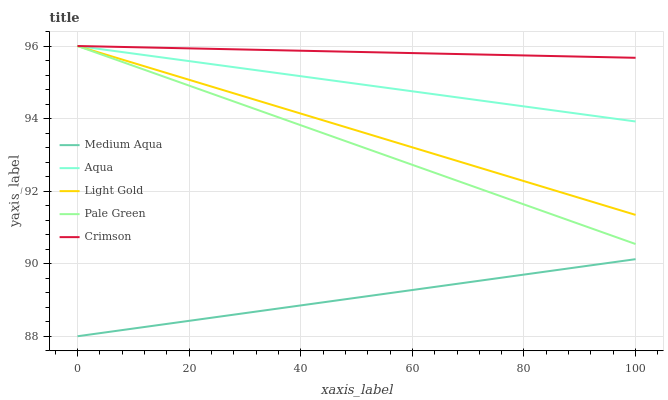Does Medium Aqua have the minimum area under the curve?
Answer yes or no. Yes. Does Crimson have the maximum area under the curve?
Answer yes or no. Yes. Does Aqua have the minimum area under the curve?
Answer yes or no. No. Does Aqua have the maximum area under the curve?
Answer yes or no. No. Is Crimson the smoothest?
Answer yes or no. Yes. Is Pale Green the roughest?
Answer yes or no. Yes. Is Pale Green the smoothest?
Answer yes or no. No. Is Light Gold the roughest?
Answer yes or no. No. Does Medium Aqua have the lowest value?
Answer yes or no. Yes. Does Aqua have the lowest value?
Answer yes or no. No. Does Light Gold have the highest value?
Answer yes or no. Yes. Does Medium Aqua have the highest value?
Answer yes or no. No. Is Medium Aqua less than Light Gold?
Answer yes or no. Yes. Is Aqua greater than Medium Aqua?
Answer yes or no. Yes. Does Light Gold intersect Crimson?
Answer yes or no. Yes. Is Light Gold less than Crimson?
Answer yes or no. No. Is Light Gold greater than Crimson?
Answer yes or no. No. Does Medium Aqua intersect Light Gold?
Answer yes or no. No. 